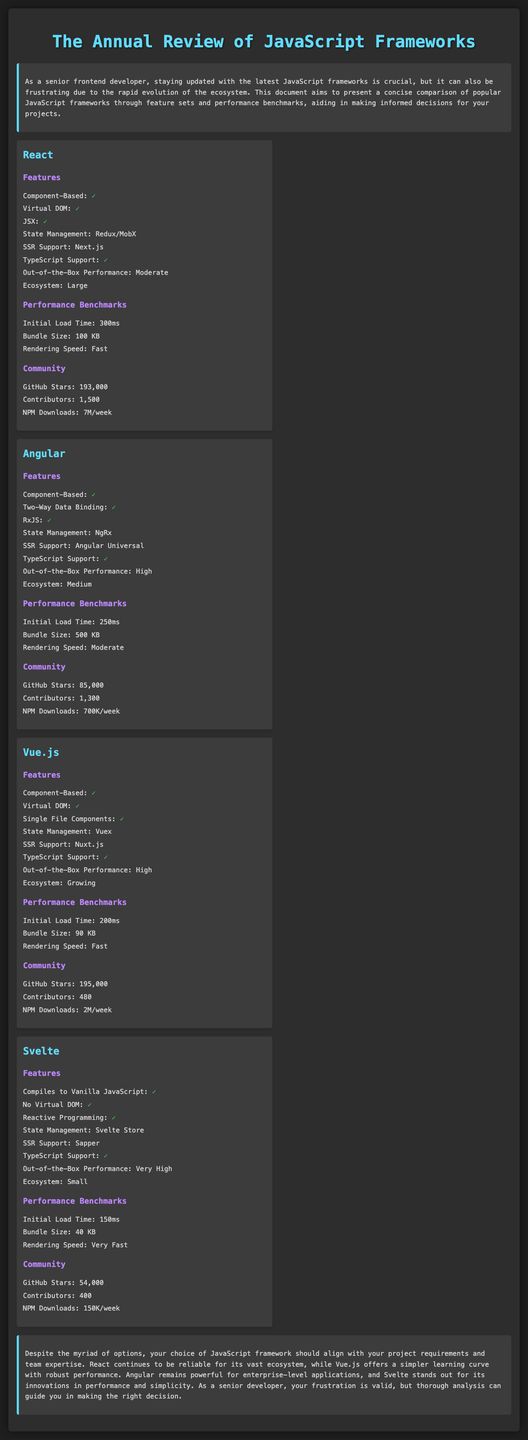What is the initial load time for React? The initial load time for React is specified in the performance benchmarks section of the document.
Answer: 300ms Which framework has the smallest bundle size? The bundle size for each framework is provided in the performance sections, and Svelte has the smallest size.
Answer: 40 KB How many GitHub stars does Vue.js have? The number of GitHub stars for Vue.js can be found in the community section of the document.
Answer: 195,000 What is the out-of-the-box performance of Angular? The out-of-the-box performance is listed in the features section for each framework, indicating Angular's performance level.
Answer: High Which framework supports TypeScript? The features section mentions which frameworks support TypeScript, and all listed frameworks do.
Answer: ✓ What is the rendering speed of Svelte? The rendering speed can be found in the performance benchmarks for Svelte within the document.
Answer: Very Fast Which framework has the largest ecosystem? The ecosystem size for each framework is noted in the features section, indicating React's ecosystem size.
Answer: Large How many contributors does Svelte have? The number of contributors for Svelte can be sourced from the community section of the document.
Answer: 400 What SSR support does Vue.js offer? SSR support for each framework is listed in the features section, specifically identifying Vue.js's support.
Answer: Nuxt.js 